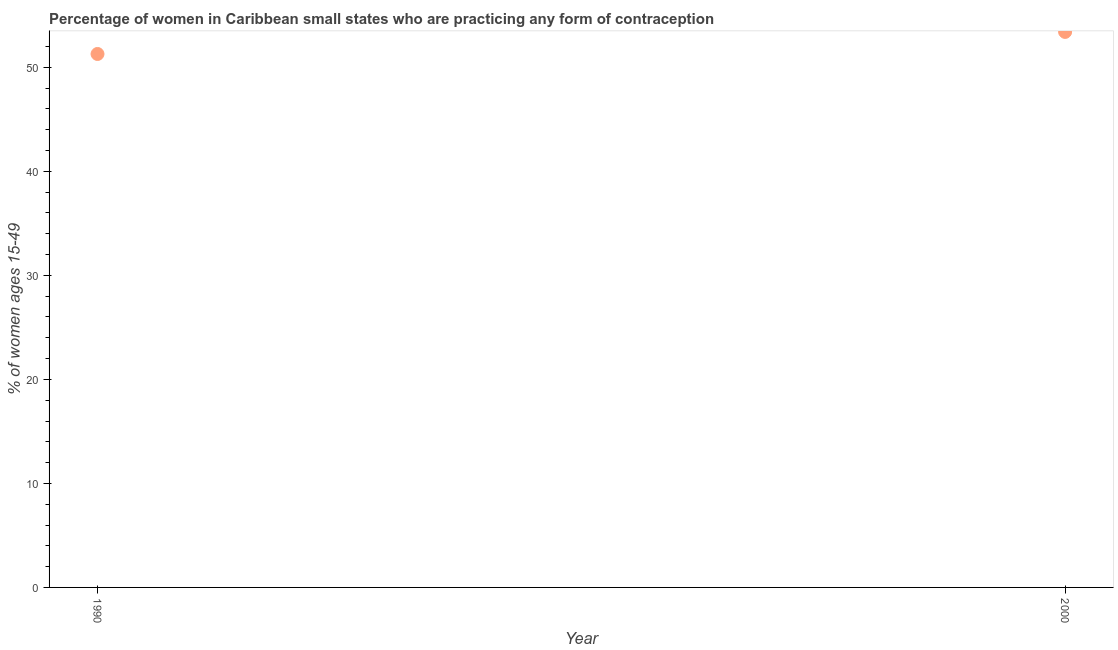What is the contraceptive prevalence in 1990?
Provide a short and direct response. 51.28. Across all years, what is the maximum contraceptive prevalence?
Your answer should be very brief. 53.4. Across all years, what is the minimum contraceptive prevalence?
Your response must be concise. 51.28. In which year was the contraceptive prevalence minimum?
Offer a terse response. 1990. What is the sum of the contraceptive prevalence?
Offer a terse response. 104.69. What is the difference between the contraceptive prevalence in 1990 and 2000?
Your answer should be compact. -2.12. What is the average contraceptive prevalence per year?
Give a very brief answer. 52.34. What is the median contraceptive prevalence?
Ensure brevity in your answer.  52.34. In how many years, is the contraceptive prevalence greater than 32 %?
Keep it short and to the point. 2. Do a majority of the years between 2000 and 1990 (inclusive) have contraceptive prevalence greater than 16 %?
Keep it short and to the point. No. What is the ratio of the contraceptive prevalence in 1990 to that in 2000?
Offer a terse response. 0.96. Is the contraceptive prevalence in 1990 less than that in 2000?
Give a very brief answer. Yes. In how many years, is the contraceptive prevalence greater than the average contraceptive prevalence taken over all years?
Your answer should be compact. 1. Does the contraceptive prevalence monotonically increase over the years?
Make the answer very short. Yes. How many dotlines are there?
Your answer should be compact. 1. What is the difference between two consecutive major ticks on the Y-axis?
Your answer should be compact. 10. Are the values on the major ticks of Y-axis written in scientific E-notation?
Your answer should be compact. No. Does the graph contain any zero values?
Ensure brevity in your answer.  No. Does the graph contain grids?
Offer a very short reply. No. What is the title of the graph?
Ensure brevity in your answer.  Percentage of women in Caribbean small states who are practicing any form of contraception. What is the label or title of the Y-axis?
Your answer should be very brief. % of women ages 15-49. What is the % of women ages 15-49 in 1990?
Offer a terse response. 51.28. What is the % of women ages 15-49 in 2000?
Ensure brevity in your answer.  53.4. What is the difference between the % of women ages 15-49 in 1990 and 2000?
Keep it short and to the point. -2.12. What is the ratio of the % of women ages 15-49 in 1990 to that in 2000?
Offer a very short reply. 0.96. 